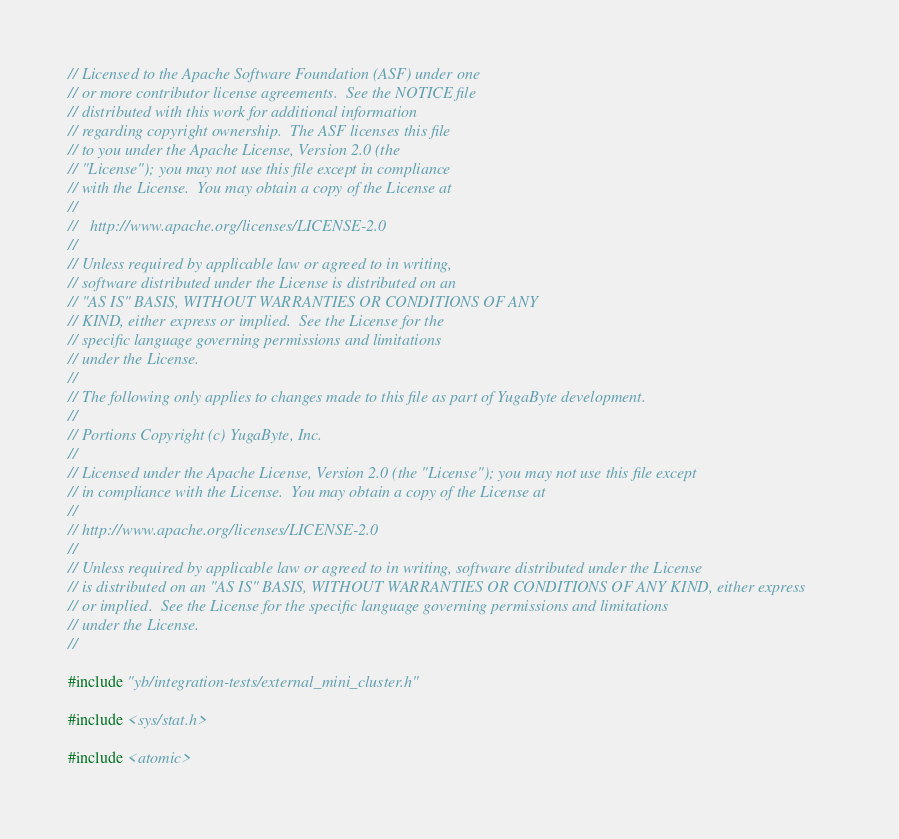<code> <loc_0><loc_0><loc_500><loc_500><_C++_>// Licensed to the Apache Software Foundation (ASF) under one
// or more contributor license agreements.  See the NOTICE file
// distributed with this work for additional information
// regarding copyright ownership.  The ASF licenses this file
// to you under the Apache License, Version 2.0 (the
// "License"); you may not use this file except in compliance
// with the License.  You may obtain a copy of the License at
//
//   http://www.apache.org/licenses/LICENSE-2.0
//
// Unless required by applicable law or agreed to in writing,
// software distributed under the License is distributed on an
// "AS IS" BASIS, WITHOUT WARRANTIES OR CONDITIONS OF ANY
// KIND, either express or implied.  See the License for the
// specific language governing permissions and limitations
// under the License.
//
// The following only applies to changes made to this file as part of YugaByte development.
//
// Portions Copyright (c) YugaByte, Inc.
//
// Licensed under the Apache License, Version 2.0 (the "License"); you may not use this file except
// in compliance with the License.  You may obtain a copy of the License at
//
// http://www.apache.org/licenses/LICENSE-2.0
//
// Unless required by applicable law or agreed to in writing, software distributed under the License
// is distributed on an "AS IS" BASIS, WITHOUT WARRANTIES OR CONDITIONS OF ANY KIND, either express
// or implied.  See the License for the specific language governing permissions and limitations
// under the License.
//

#include "yb/integration-tests/external_mini_cluster.h"

#include <sys/stat.h>

#include <atomic></code> 